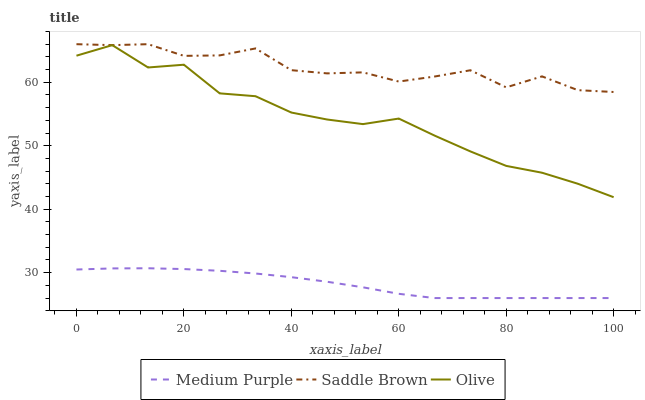Does Olive have the minimum area under the curve?
Answer yes or no. No. Does Olive have the maximum area under the curve?
Answer yes or no. No. Is Olive the smoothest?
Answer yes or no. No. Is Olive the roughest?
Answer yes or no. No. Does Olive have the lowest value?
Answer yes or no. No. Does Olive have the highest value?
Answer yes or no. No. Is Medium Purple less than Olive?
Answer yes or no. Yes. Is Olive greater than Medium Purple?
Answer yes or no. Yes. Does Medium Purple intersect Olive?
Answer yes or no. No. 